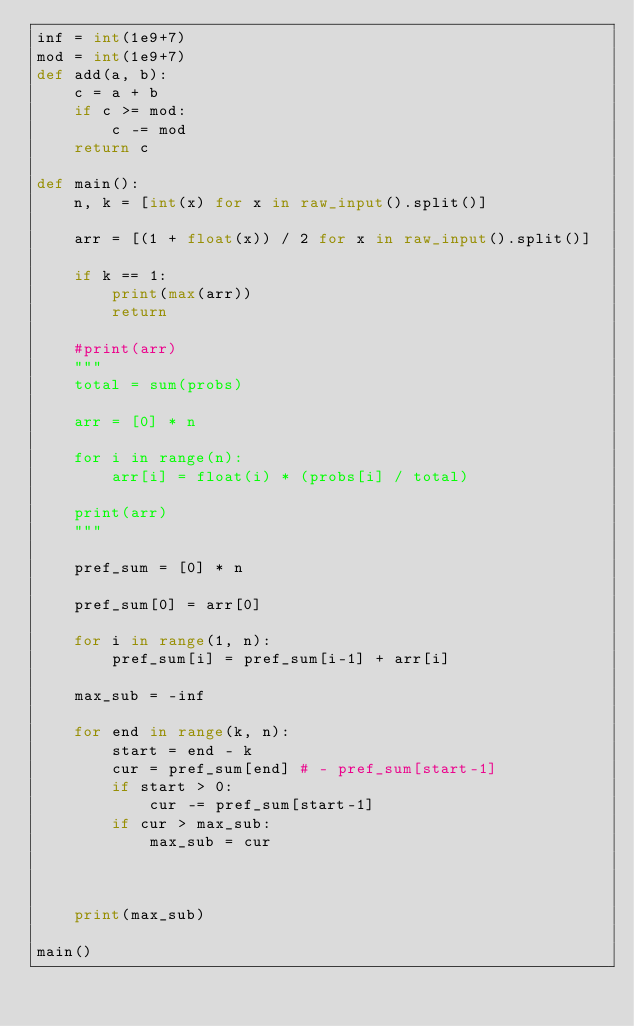<code> <loc_0><loc_0><loc_500><loc_500><_Python_>inf = int(1e9+7)
mod = int(1e9+7)
def add(a, b):
    c = a + b
    if c >= mod:
        c -= mod
    return c

def main():
    n, k = [int(x) for x in raw_input().split()]
    
    arr = [(1 + float(x)) / 2 for x in raw_input().split()]
    
    if k == 1:
        print(max(arr))
        return
    
    #print(arr)
    """
    total = sum(probs)
    
    arr = [0] * n
    
    for i in range(n):
        arr[i] = float(i) * (probs[i] / total)
    
    print(arr)
    """
    
    pref_sum = [0] * n
    
    pref_sum[0] = arr[0]
    
    for i in range(1, n):
        pref_sum[i] = pref_sum[i-1] + arr[i]
    
    max_sub = -inf
    
    for end in range(k, n):
        start = end - k
        cur = pref_sum[end] # - pref_sum[start-1]
        if start > 0:
            cur -= pref_sum[start-1]
        if cur > max_sub:
            max_sub = cur
        
    
    
    print(max_sub)

main()</code> 